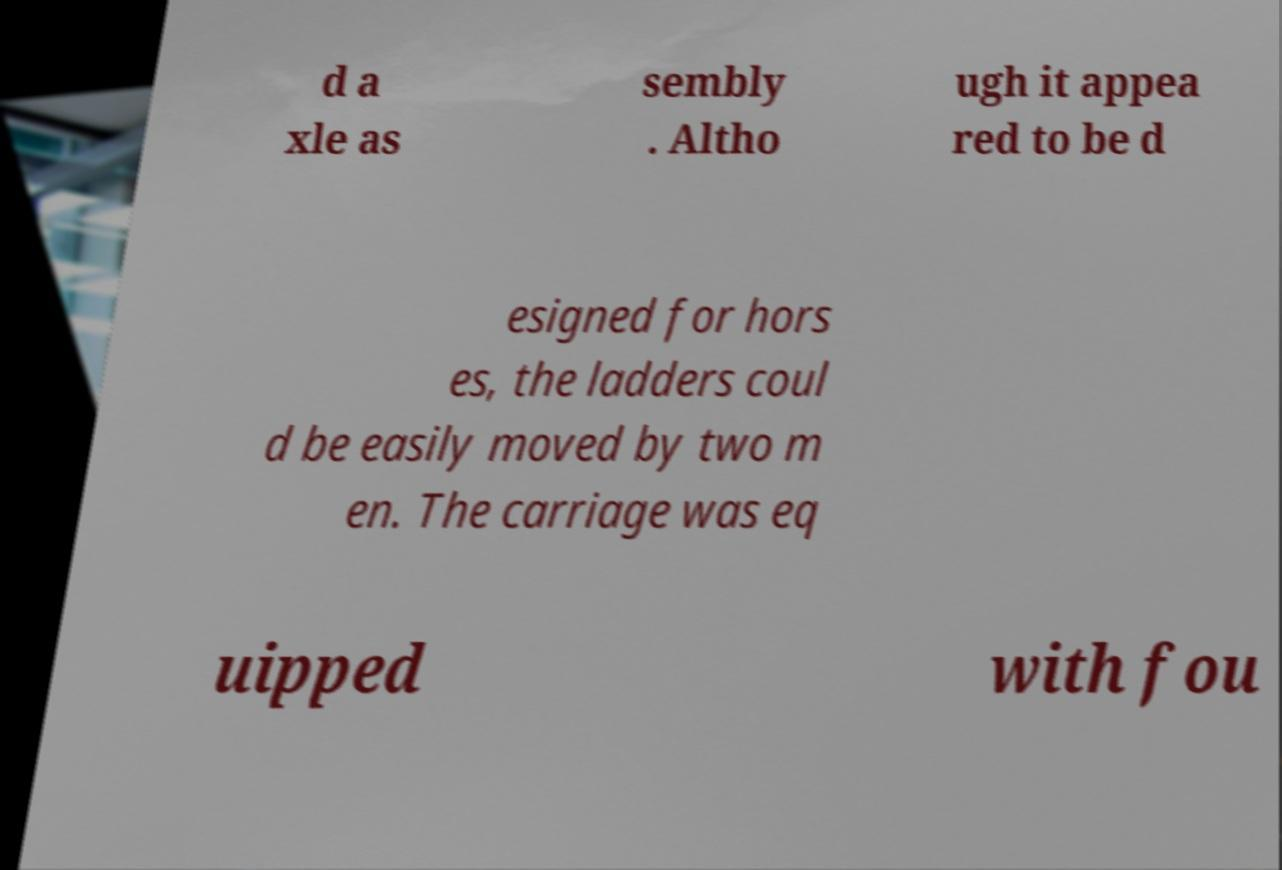What messages or text are displayed in this image? I need them in a readable, typed format. d a xle as sembly . Altho ugh it appea red to be d esigned for hors es, the ladders coul d be easily moved by two m en. The carriage was eq uipped with fou 